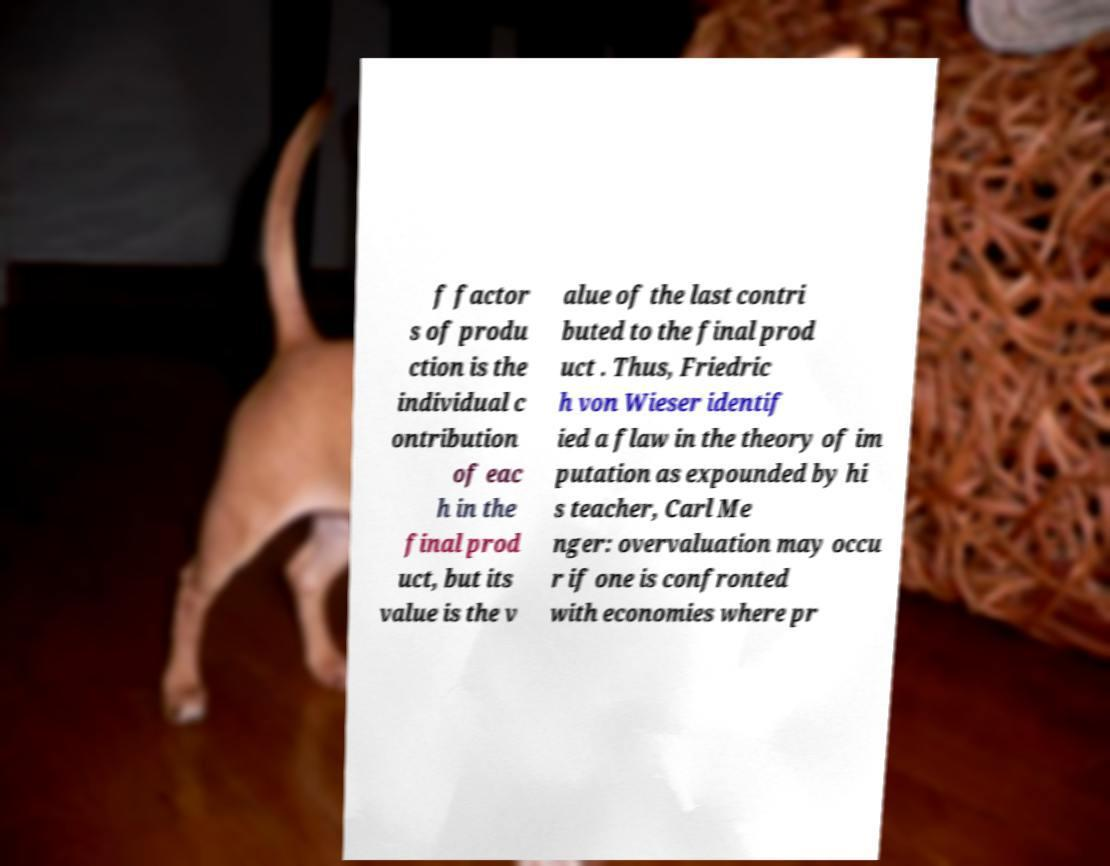Could you extract and type out the text from this image? f factor s of produ ction is the individual c ontribution of eac h in the final prod uct, but its value is the v alue of the last contri buted to the final prod uct . Thus, Friedric h von Wieser identif ied a flaw in the theory of im putation as expounded by hi s teacher, Carl Me nger: overvaluation may occu r if one is confronted with economies where pr 